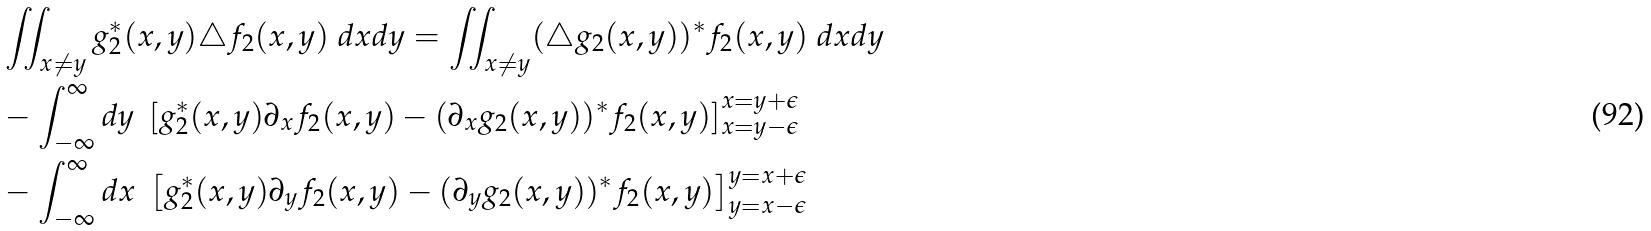<formula> <loc_0><loc_0><loc_500><loc_500>& \iint _ { x \neq y } g _ { 2 } ^ { \ast } ( x , y ) \triangle f _ { 2 } ( x , y ) \ d x d y = \iint _ { x \neq y } ( \triangle g _ { 2 } ( x , y ) ) ^ { \ast } f _ { 2 } ( x , y ) \ d x d y \\ & - \int _ { - \infty } ^ { \infty } d y \ \left [ g _ { 2 } ^ { \ast } ( x , y ) \partial _ { x } f _ { 2 } ( x , y ) - ( \partial _ { x } g _ { 2 } ( x , y ) ) ^ { \ast } f _ { 2 } ( x , y ) \right ] _ { x = y - \epsilon } ^ { x = y + \epsilon } \\ & - \int _ { - \infty } ^ { \infty } d x \ \left [ g _ { 2 } ^ { \ast } ( x , y ) \partial _ { y } f _ { 2 } ( x , y ) - ( \partial _ { y } g _ { 2 } ( x , y ) ) ^ { \ast } f _ { 2 } ( x , y ) \right ] _ { y = x - \epsilon } ^ { y = x + \epsilon }</formula> 